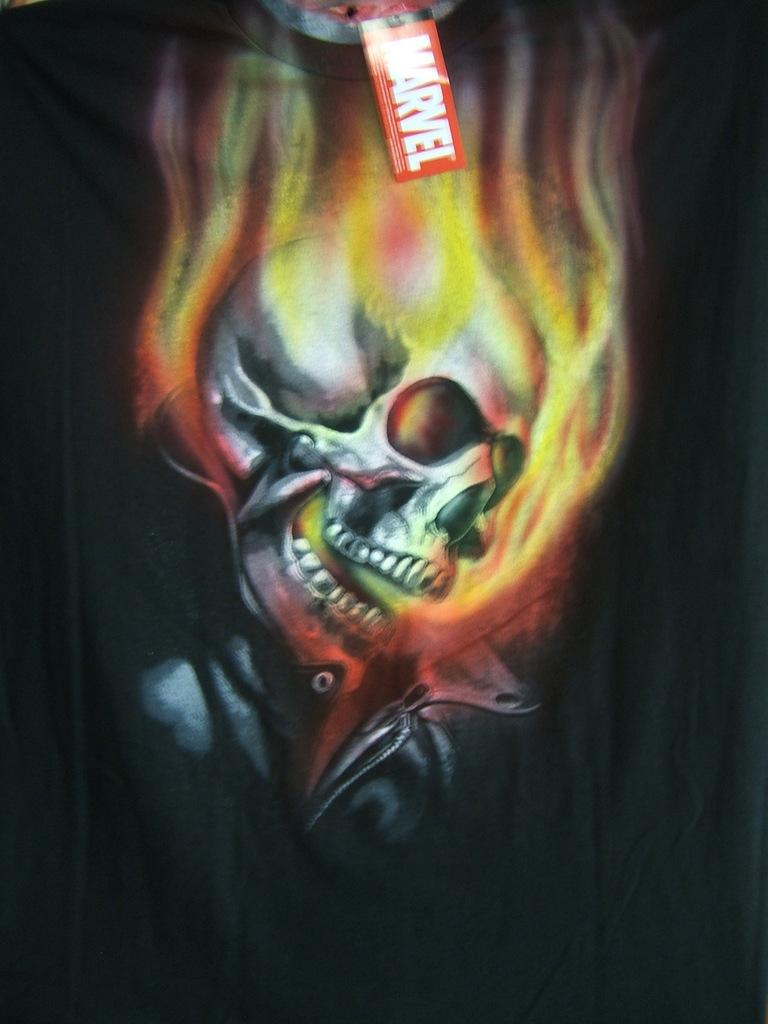What type of image is being described? The image is animated. What type of stew is being cooked in the image? There is no stew present in the image, as it is an animated image. What kind of flowers can be seen growing in the image? The image is animated, and there is no mention of flowers or any other specific objects or scenes. 